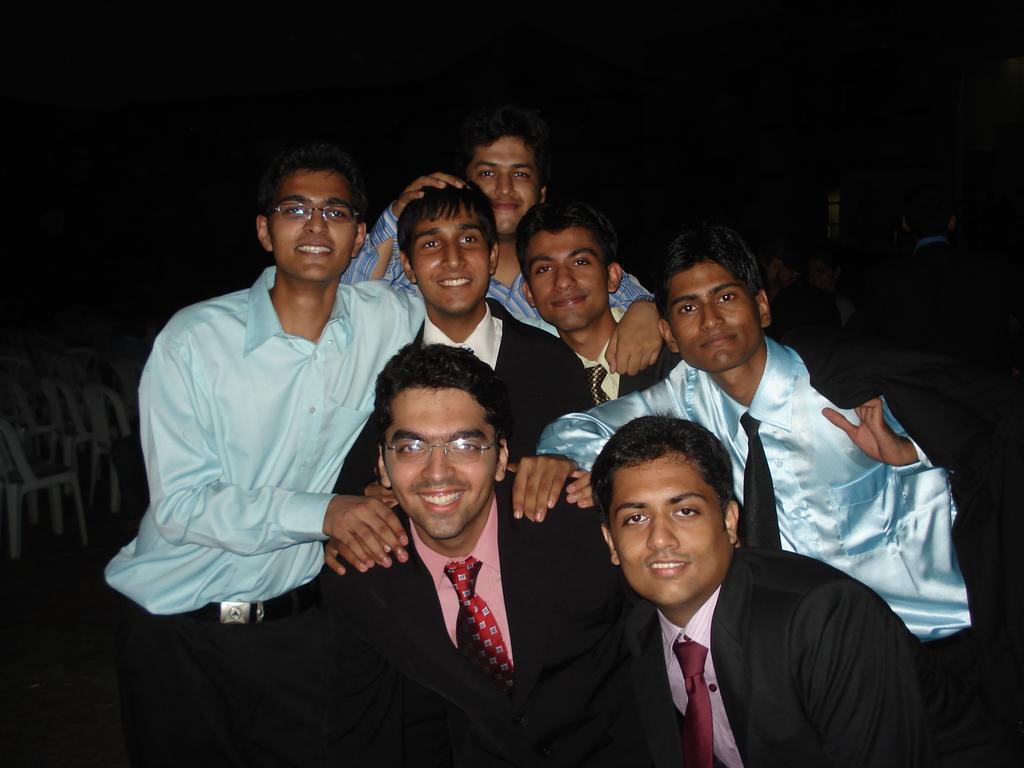Describe this image in one or two sentences. Here in this picture we can see a group of people standing on the ground over there and we can see some of them are wearing coats on them and all of them are smiling and behind them we can see chairs and people present all over there. 